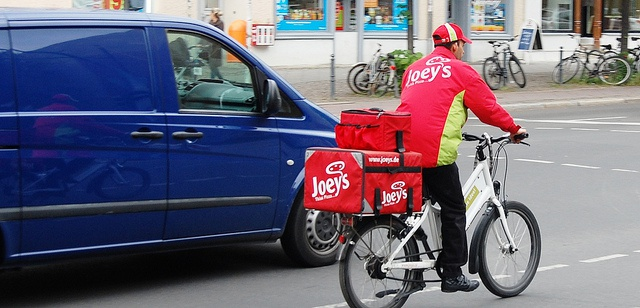Describe the objects in this image and their specific colors. I can see car in ivory, navy, black, gray, and darkblue tones, bicycle in ivory, darkgray, black, lightgray, and gray tones, people in ivory, black, salmon, and red tones, suitcase in ivory, brown, white, and black tones, and bicycle in ivory, darkgray, gray, lightgray, and black tones in this image. 